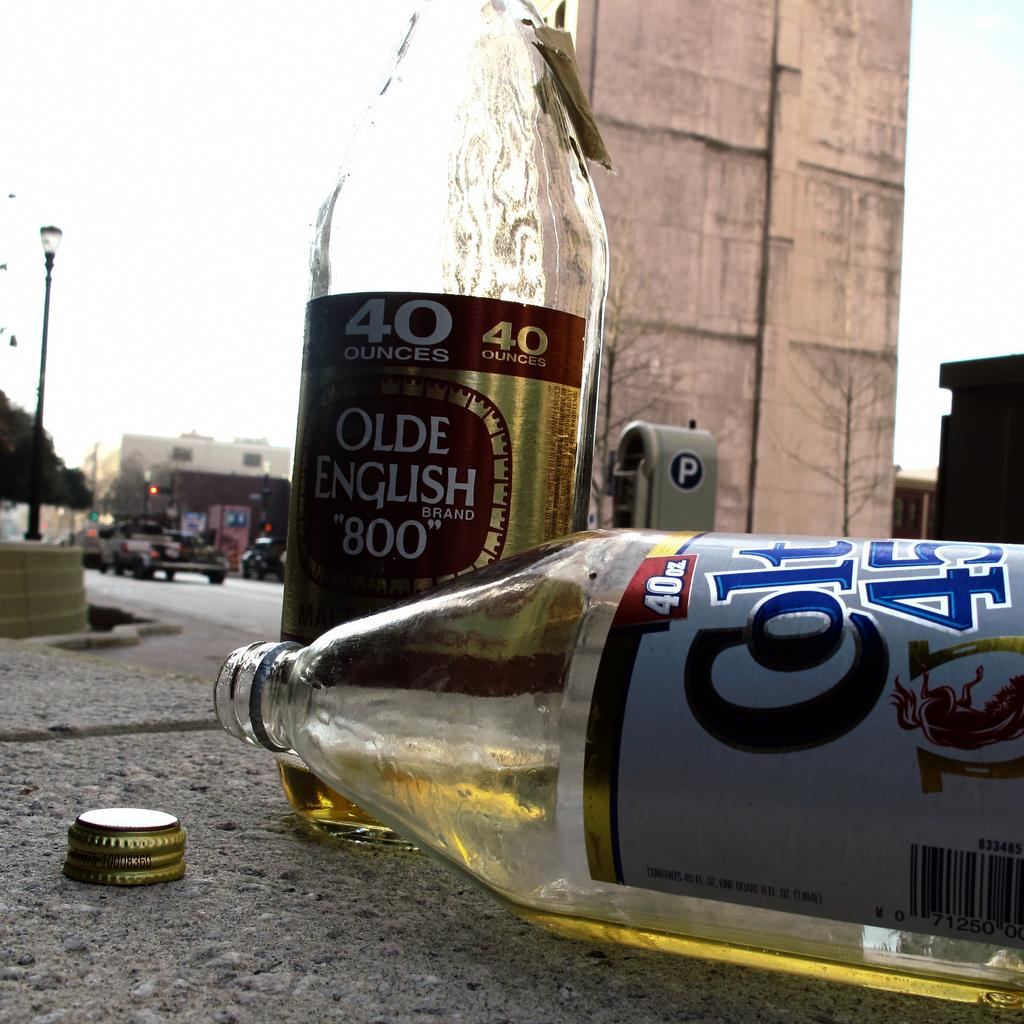<image>
Relay a brief, clear account of the picture shown. Two malt liquor bottles, Olde English 800 and Colt 45, lie on the pavement. 